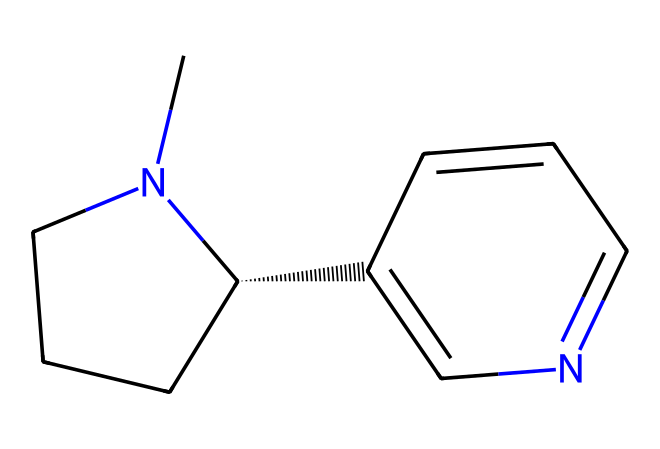What is the molecular formula of nicotine? To determine the molecular formula, count the number of carbon (C), hydrogen (H), and nitrogen (N) atoms from the SMILES representation. There are 10 carbon atoms, 14 hydrogen atoms, and 2 nitrogen atoms, resulting in the formula C10H14N2.
Answer: C10H14N2 How many nitrogen atoms are present in nicotine? By analyzing the SMILES, identify the presence of nitrogen symbols (N) in the structure. There are 2 nitrogen atoms in the chemical structure of nicotine.
Answer: 2 What type of alkaloid is nicotine classified as? Nicotine is classified as a tertiary alkaloid due to the presence of a tertiary amine in its structure, which involves a nitrogen atom bonded to three carbon atoms.
Answer: tertiary How many rings are present in nicotine's structure? Inspect the SMILES representation and look for any cyclic structures, which are indicated by the numbers indicating the start and end of rings. Nicotine has 2 rings in its chemical structure.
Answer: 2 What characteristic functional group is present in nicotine? Analyzing the SMILES, observe the presence of a nitrogen atom in a ring structure, indicating that this compound contains the amine functional group, which is a characteristic of alkaloids.
Answer: amine What is the significance of the stereochemistry in nicotine? The SMILES notation indicates that nicotine possesses a chiral center (C@H), meaning it has a specific stereoisomerism that could affect its biological activity and pharmacological properties.
Answer: chiral What is the role of nicotine in the tobacco plant? Nicotine serves as a natural insecticide for the tobacco plant, deterring pests by being toxic, which is a common trait for many alkaloids in plants.
Answer: insecticide 